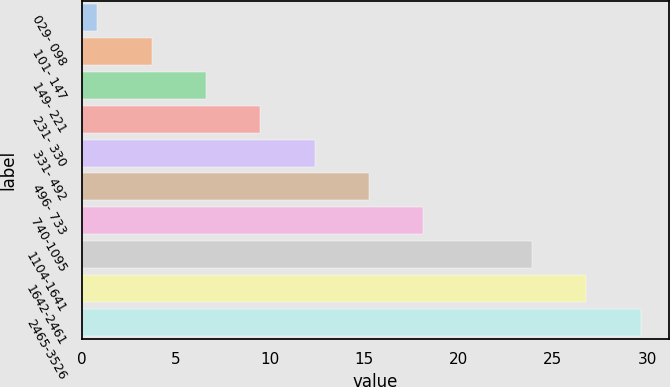<chart> <loc_0><loc_0><loc_500><loc_500><bar_chart><fcel>029- 098<fcel>101- 147<fcel>149- 221<fcel>231- 330<fcel>331- 492<fcel>496- 733<fcel>740-1095<fcel>1104-1641<fcel>1642-2461<fcel>2465-3526<nl><fcel>0.84<fcel>3.72<fcel>6.6<fcel>9.48<fcel>12.36<fcel>15.24<fcel>18.12<fcel>23.88<fcel>26.76<fcel>29.68<nl></chart> 